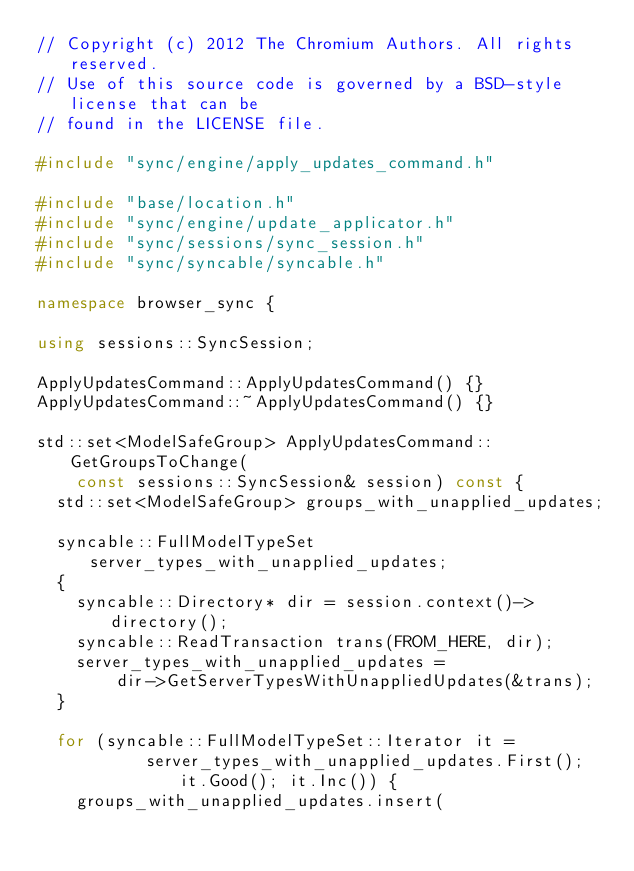Convert code to text. <code><loc_0><loc_0><loc_500><loc_500><_C++_>// Copyright (c) 2012 The Chromium Authors. All rights reserved.
// Use of this source code is governed by a BSD-style license that can be
// found in the LICENSE file.

#include "sync/engine/apply_updates_command.h"

#include "base/location.h"
#include "sync/engine/update_applicator.h"
#include "sync/sessions/sync_session.h"
#include "sync/syncable/syncable.h"

namespace browser_sync {

using sessions::SyncSession;

ApplyUpdatesCommand::ApplyUpdatesCommand() {}
ApplyUpdatesCommand::~ApplyUpdatesCommand() {}

std::set<ModelSafeGroup> ApplyUpdatesCommand::GetGroupsToChange(
    const sessions::SyncSession& session) const {
  std::set<ModelSafeGroup> groups_with_unapplied_updates;

  syncable::FullModelTypeSet server_types_with_unapplied_updates;
  {
    syncable::Directory* dir = session.context()->directory();
    syncable::ReadTransaction trans(FROM_HERE, dir);
    server_types_with_unapplied_updates =
        dir->GetServerTypesWithUnappliedUpdates(&trans);
  }

  for (syncable::FullModelTypeSet::Iterator it =
           server_types_with_unapplied_updates.First(); it.Good(); it.Inc()) {
    groups_with_unapplied_updates.insert(</code> 